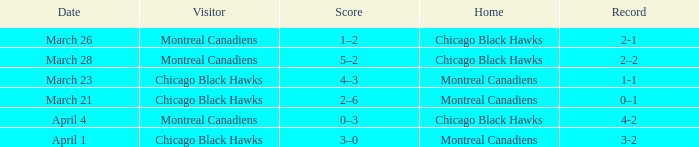What is the score for the team with a record of 2-1? 1–2. 